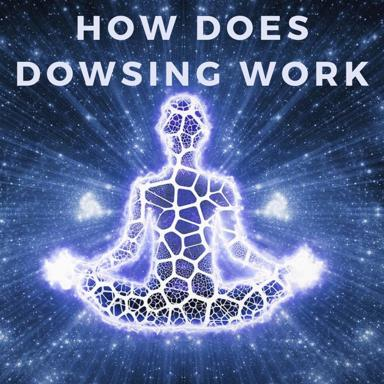How might the visual elements in this image relate to the concepts behind dowsing? The image combines elements of spiritual iconography with cosmic motifs, suggesting a link between the inner, intuitive realms of human consciousness and the expansive, mysterious nature of the universe. In terms of dowsing, this can be interpreted as a metaphor for the dowser’s supposed ability to tap into hidden energies and resources, much like connecting with the vast unknown of the cosmos. 